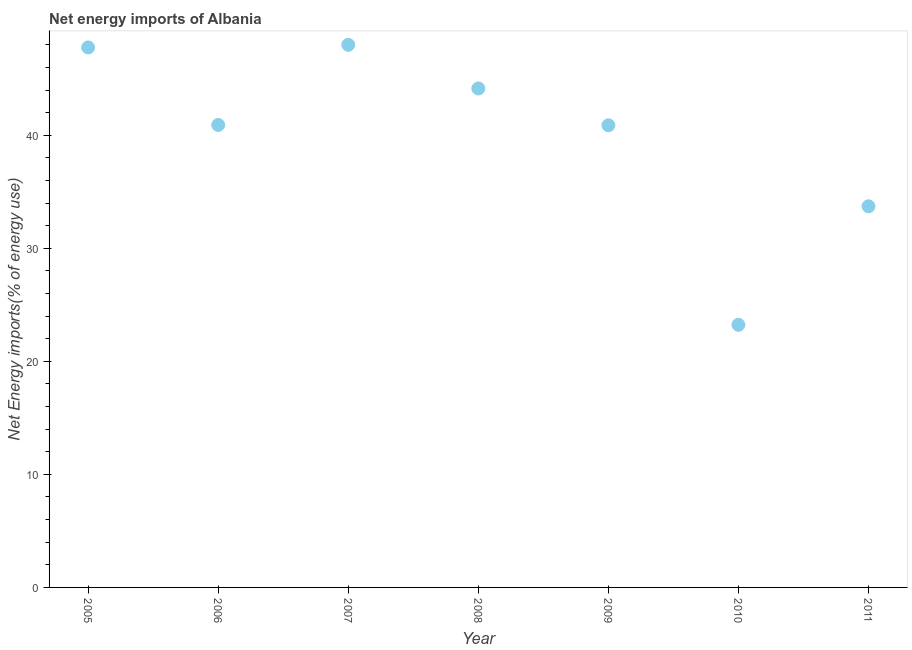What is the energy imports in 2006?
Your answer should be compact. 40.91. Across all years, what is the maximum energy imports?
Make the answer very short. 48. Across all years, what is the minimum energy imports?
Make the answer very short. 23.23. In which year was the energy imports maximum?
Your answer should be very brief. 2007. In which year was the energy imports minimum?
Give a very brief answer. 2010. What is the sum of the energy imports?
Provide a short and direct response. 278.64. What is the difference between the energy imports in 2009 and 2010?
Offer a terse response. 17.65. What is the average energy imports per year?
Offer a very short reply. 39.81. What is the median energy imports?
Give a very brief answer. 40.91. Do a majority of the years between 2009 and 2008 (inclusive) have energy imports greater than 34 %?
Keep it short and to the point. No. What is the ratio of the energy imports in 2005 to that in 2006?
Keep it short and to the point. 1.17. Is the difference between the energy imports in 2005 and 2006 greater than the difference between any two years?
Provide a short and direct response. No. What is the difference between the highest and the second highest energy imports?
Give a very brief answer. 0.23. Is the sum of the energy imports in 2005 and 2007 greater than the maximum energy imports across all years?
Provide a succinct answer. Yes. What is the difference between the highest and the lowest energy imports?
Offer a very short reply. 24.77. In how many years, is the energy imports greater than the average energy imports taken over all years?
Keep it short and to the point. 5. How many dotlines are there?
Keep it short and to the point. 1. Does the graph contain any zero values?
Your answer should be compact. No. What is the title of the graph?
Offer a very short reply. Net energy imports of Albania. What is the label or title of the X-axis?
Provide a succinct answer. Year. What is the label or title of the Y-axis?
Make the answer very short. Net Energy imports(% of energy use). What is the Net Energy imports(% of energy use) in 2005?
Your response must be concise. 47.77. What is the Net Energy imports(% of energy use) in 2006?
Offer a terse response. 40.91. What is the Net Energy imports(% of energy use) in 2007?
Your response must be concise. 48. What is the Net Energy imports(% of energy use) in 2008?
Your answer should be compact. 44.14. What is the Net Energy imports(% of energy use) in 2009?
Offer a very short reply. 40.88. What is the Net Energy imports(% of energy use) in 2010?
Give a very brief answer. 23.23. What is the Net Energy imports(% of energy use) in 2011?
Offer a terse response. 33.72. What is the difference between the Net Energy imports(% of energy use) in 2005 and 2006?
Provide a short and direct response. 6.86. What is the difference between the Net Energy imports(% of energy use) in 2005 and 2007?
Your answer should be very brief. -0.23. What is the difference between the Net Energy imports(% of energy use) in 2005 and 2008?
Keep it short and to the point. 3.63. What is the difference between the Net Energy imports(% of energy use) in 2005 and 2009?
Keep it short and to the point. 6.88. What is the difference between the Net Energy imports(% of energy use) in 2005 and 2010?
Give a very brief answer. 24.54. What is the difference between the Net Energy imports(% of energy use) in 2005 and 2011?
Keep it short and to the point. 14.05. What is the difference between the Net Energy imports(% of energy use) in 2006 and 2007?
Your answer should be very brief. -7.09. What is the difference between the Net Energy imports(% of energy use) in 2006 and 2008?
Your response must be concise. -3.23. What is the difference between the Net Energy imports(% of energy use) in 2006 and 2009?
Offer a terse response. 0.03. What is the difference between the Net Energy imports(% of energy use) in 2006 and 2010?
Your response must be concise. 17.68. What is the difference between the Net Energy imports(% of energy use) in 2006 and 2011?
Provide a succinct answer. 7.19. What is the difference between the Net Energy imports(% of energy use) in 2007 and 2008?
Your answer should be very brief. 3.86. What is the difference between the Net Energy imports(% of energy use) in 2007 and 2009?
Your answer should be very brief. 7.12. What is the difference between the Net Energy imports(% of energy use) in 2007 and 2010?
Provide a short and direct response. 24.77. What is the difference between the Net Energy imports(% of energy use) in 2007 and 2011?
Your response must be concise. 14.28. What is the difference between the Net Energy imports(% of energy use) in 2008 and 2009?
Give a very brief answer. 3.26. What is the difference between the Net Energy imports(% of energy use) in 2008 and 2010?
Your answer should be compact. 20.91. What is the difference between the Net Energy imports(% of energy use) in 2008 and 2011?
Ensure brevity in your answer.  10.42. What is the difference between the Net Energy imports(% of energy use) in 2009 and 2010?
Offer a terse response. 17.65. What is the difference between the Net Energy imports(% of energy use) in 2009 and 2011?
Provide a succinct answer. 7.17. What is the difference between the Net Energy imports(% of energy use) in 2010 and 2011?
Give a very brief answer. -10.49. What is the ratio of the Net Energy imports(% of energy use) in 2005 to that in 2006?
Ensure brevity in your answer.  1.17. What is the ratio of the Net Energy imports(% of energy use) in 2005 to that in 2008?
Your answer should be compact. 1.08. What is the ratio of the Net Energy imports(% of energy use) in 2005 to that in 2009?
Your response must be concise. 1.17. What is the ratio of the Net Energy imports(% of energy use) in 2005 to that in 2010?
Ensure brevity in your answer.  2.06. What is the ratio of the Net Energy imports(% of energy use) in 2005 to that in 2011?
Keep it short and to the point. 1.42. What is the ratio of the Net Energy imports(% of energy use) in 2006 to that in 2007?
Offer a very short reply. 0.85. What is the ratio of the Net Energy imports(% of energy use) in 2006 to that in 2008?
Make the answer very short. 0.93. What is the ratio of the Net Energy imports(% of energy use) in 2006 to that in 2010?
Your response must be concise. 1.76. What is the ratio of the Net Energy imports(% of energy use) in 2006 to that in 2011?
Your response must be concise. 1.21. What is the ratio of the Net Energy imports(% of energy use) in 2007 to that in 2008?
Keep it short and to the point. 1.09. What is the ratio of the Net Energy imports(% of energy use) in 2007 to that in 2009?
Your answer should be compact. 1.17. What is the ratio of the Net Energy imports(% of energy use) in 2007 to that in 2010?
Offer a very short reply. 2.07. What is the ratio of the Net Energy imports(% of energy use) in 2007 to that in 2011?
Make the answer very short. 1.42. What is the ratio of the Net Energy imports(% of energy use) in 2008 to that in 2009?
Your answer should be very brief. 1.08. What is the ratio of the Net Energy imports(% of energy use) in 2008 to that in 2010?
Your answer should be very brief. 1.9. What is the ratio of the Net Energy imports(% of energy use) in 2008 to that in 2011?
Your response must be concise. 1.31. What is the ratio of the Net Energy imports(% of energy use) in 2009 to that in 2010?
Keep it short and to the point. 1.76. What is the ratio of the Net Energy imports(% of energy use) in 2009 to that in 2011?
Keep it short and to the point. 1.21. What is the ratio of the Net Energy imports(% of energy use) in 2010 to that in 2011?
Provide a succinct answer. 0.69. 